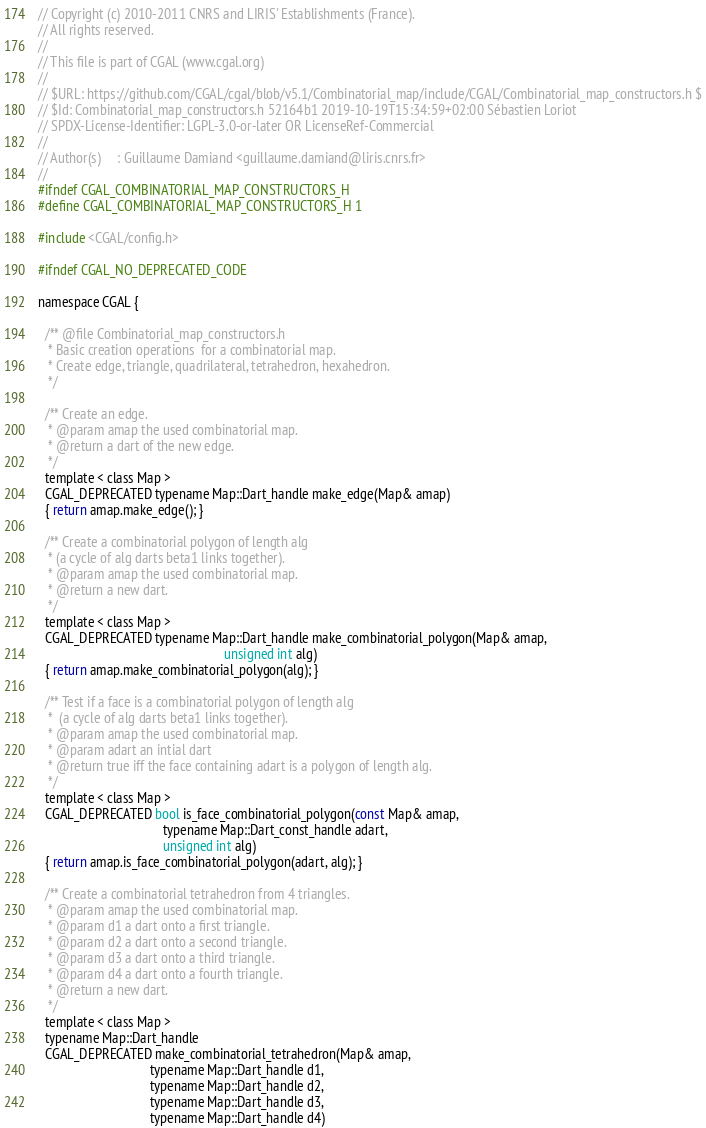<code> <loc_0><loc_0><loc_500><loc_500><_C_>// Copyright (c) 2010-2011 CNRS and LIRIS' Establishments (France).
// All rights reserved.
//
// This file is part of CGAL (www.cgal.org)
//
// $URL: https://github.com/CGAL/cgal/blob/v5.1/Combinatorial_map/include/CGAL/Combinatorial_map_constructors.h $
// $Id: Combinatorial_map_constructors.h 52164b1 2019-10-19T15:34:59+02:00 Sébastien Loriot
// SPDX-License-Identifier: LGPL-3.0-or-later OR LicenseRef-Commercial
//
// Author(s)     : Guillaume Damiand <guillaume.damiand@liris.cnrs.fr>
//
#ifndef CGAL_COMBINATORIAL_MAP_CONSTRUCTORS_H
#define CGAL_COMBINATORIAL_MAP_CONSTRUCTORS_H 1

#include <CGAL/config.h>

#ifndef CGAL_NO_DEPRECATED_CODE

namespace CGAL {

  /** @file Combinatorial_map_constructors.h
   * Basic creation operations  for a combinatorial map.
   * Create edge, triangle, quadrilateral, tetrahedron, hexahedron.
   */

  /** Create an edge.
   * @param amap the used combinatorial map.
   * @return a dart of the new edge.
   */
  template < class Map >
  CGAL_DEPRECATED typename Map::Dart_handle make_edge(Map& amap)
  { return amap.make_edge(); }

  /** Create a combinatorial polygon of length alg
   * (a cycle of alg darts beta1 links together).
   * @param amap the used combinatorial map.
   * @return a new dart.
   */
  template < class Map >
  CGAL_DEPRECATED typename Map::Dart_handle make_combinatorial_polygon(Map& amap,
                                                       unsigned int alg)
  { return amap.make_combinatorial_polygon(alg); }

  /** Test if a face is a combinatorial polygon of length alg
   *  (a cycle of alg darts beta1 links together).
   * @param amap the used combinatorial map.
   * @param adart an intial dart
   * @return true iff the face containing adart is a polygon of length alg.
   */
  template < class Map >
  CGAL_DEPRECATED bool is_face_combinatorial_polygon(const Map& amap,
                                     typename Map::Dart_const_handle adart,
                                     unsigned int alg)
  { return amap.is_face_combinatorial_polygon(adart, alg); }

  /** Create a combinatorial tetrahedron from 4 triangles.
   * @param amap the used combinatorial map.
   * @param d1 a dart onto a first triangle.
   * @param d2 a dart onto a second triangle.
   * @param d3 a dart onto a third triangle.
   * @param d4 a dart onto a fourth triangle.
   * @return a new dart.
   */
  template < class Map >
  typename Map::Dart_handle
  CGAL_DEPRECATED make_combinatorial_tetrahedron(Map& amap,
                                 typename Map::Dart_handle d1,
                                 typename Map::Dart_handle d2,
                                 typename Map::Dart_handle d3,
                                 typename Map::Dart_handle d4)</code> 